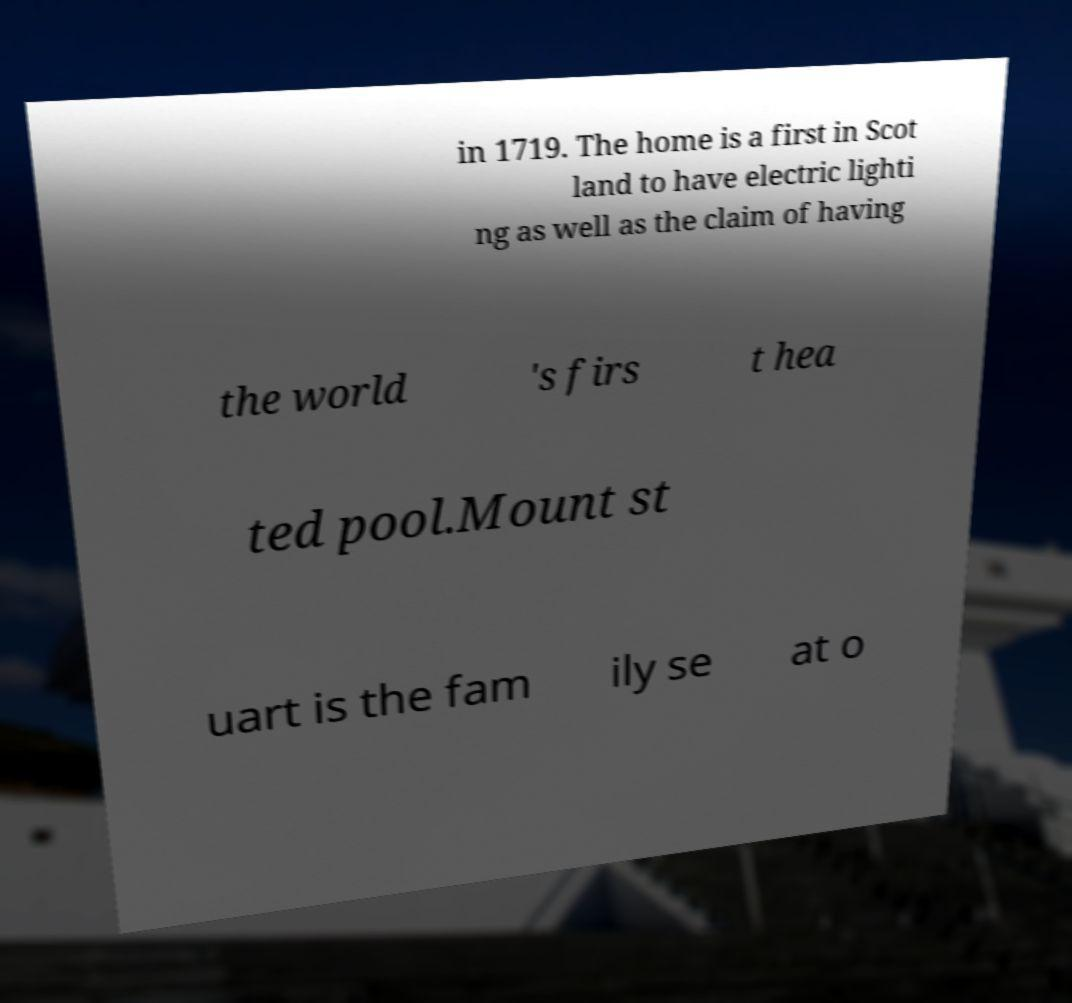Please read and relay the text visible in this image. What does it say? in 1719. The home is a first in Scot land to have electric lighti ng as well as the claim of having the world 's firs t hea ted pool.Mount st uart is the fam ily se at o 